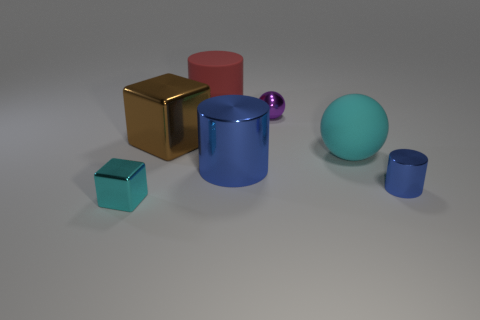Subtract all green cylinders. Subtract all cyan balls. How many cylinders are left? 3 Add 3 large shiny cubes. How many objects exist? 10 Subtract all balls. How many objects are left? 5 Subtract all big things. Subtract all large purple rubber blocks. How many objects are left? 3 Add 7 small blue cylinders. How many small blue cylinders are left? 8 Add 4 tiny red cubes. How many tiny red cubes exist? 4 Subtract 1 red cylinders. How many objects are left? 6 